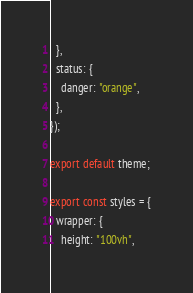Convert code to text. <code><loc_0><loc_0><loc_500><loc_500><_JavaScript_>  },
  status: {
    danger: "orange",
  },
});

export default theme;

export const styles = {
  wrapper: {
    height: "100vh",</code> 